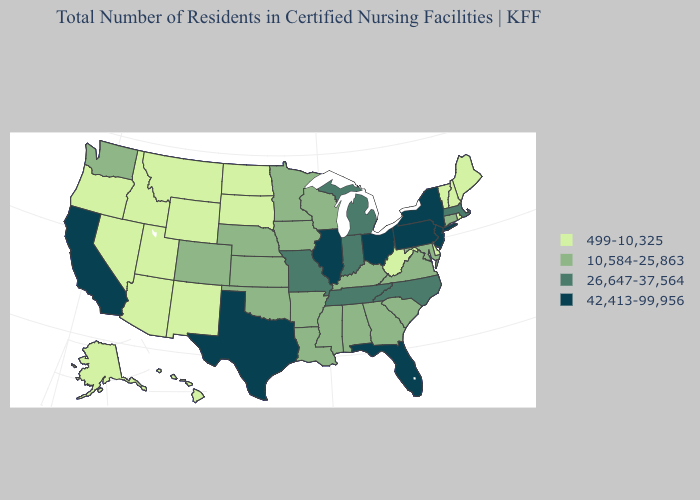Does California have the highest value in the West?
Keep it brief. Yes. Name the states that have a value in the range 499-10,325?
Short answer required. Alaska, Arizona, Delaware, Hawaii, Idaho, Maine, Montana, Nevada, New Hampshire, New Mexico, North Dakota, Oregon, Rhode Island, South Dakota, Utah, Vermont, West Virginia, Wyoming. Does West Virginia have the lowest value in the South?
Short answer required. Yes. What is the lowest value in the USA?
Concise answer only. 499-10,325. Name the states that have a value in the range 10,584-25,863?
Concise answer only. Alabama, Arkansas, Colorado, Connecticut, Georgia, Iowa, Kansas, Kentucky, Louisiana, Maryland, Minnesota, Mississippi, Nebraska, Oklahoma, South Carolina, Virginia, Washington, Wisconsin. Which states have the lowest value in the South?
Quick response, please. Delaware, West Virginia. Which states have the lowest value in the USA?
Quick response, please. Alaska, Arizona, Delaware, Hawaii, Idaho, Maine, Montana, Nevada, New Hampshire, New Mexico, North Dakota, Oregon, Rhode Island, South Dakota, Utah, Vermont, West Virginia, Wyoming. Name the states that have a value in the range 42,413-99,956?
Quick response, please. California, Florida, Illinois, New Jersey, New York, Ohio, Pennsylvania, Texas. Which states have the lowest value in the South?
Answer briefly. Delaware, West Virginia. Among the states that border Maryland , which have the lowest value?
Be succinct. Delaware, West Virginia. Does Tennessee have the lowest value in the USA?
Short answer required. No. Does Florida have a higher value than New Hampshire?
Keep it brief. Yes. Which states have the highest value in the USA?
Short answer required. California, Florida, Illinois, New Jersey, New York, Ohio, Pennsylvania, Texas. What is the lowest value in the USA?
Give a very brief answer. 499-10,325. Among the states that border Massachusetts , which have the lowest value?
Short answer required. New Hampshire, Rhode Island, Vermont. 